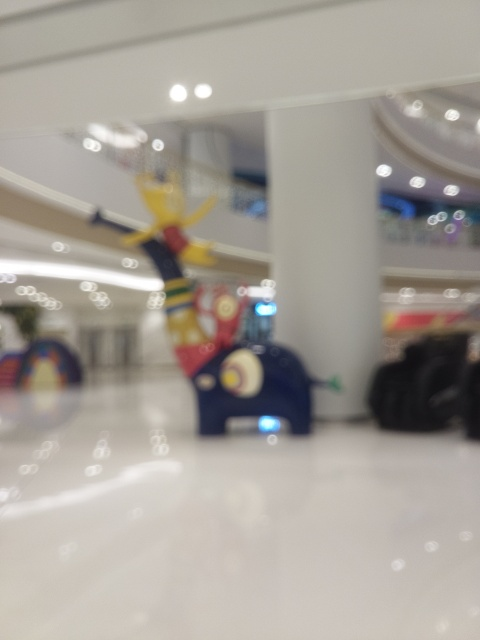Can you suggest why this image might have been taken even though it's blurry? Despite the blur, the photograph might have been intentionally captured this way to convey a sense of motion or to focus on the ambience rather than the details. Alternatively, it could have been a candid moment or an accidental press of the camera's shutter button. In artistic contexts, such images could reflect a subjective experience or the photographer's mood at the time. 